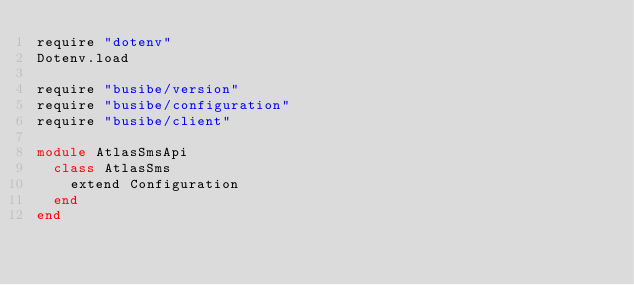Convert code to text. <code><loc_0><loc_0><loc_500><loc_500><_Ruby_>require "dotenv"
Dotenv.load

require "busibe/version"
require "busibe/configuration"
require "busibe/client"

module AtlasSmsApi
  class AtlasSms
    extend Configuration
  end
end
</code> 